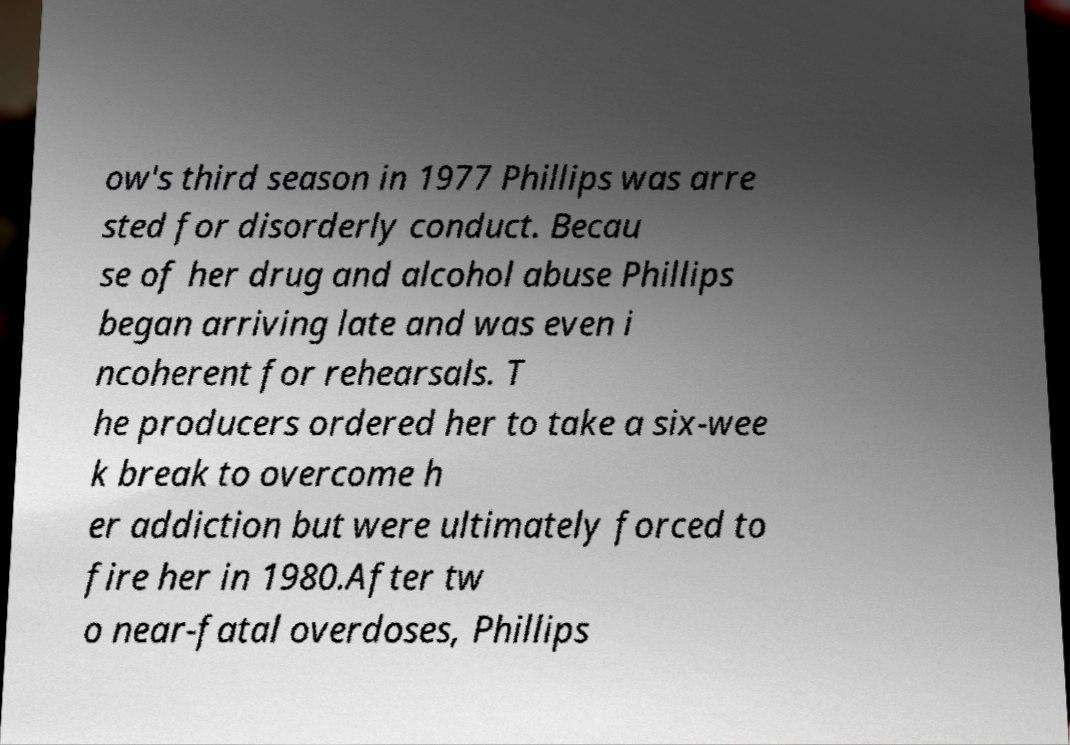Can you read and provide the text displayed in the image?This photo seems to have some interesting text. Can you extract and type it out for me? ow's third season in 1977 Phillips was arre sted for disorderly conduct. Becau se of her drug and alcohol abuse Phillips began arriving late and was even i ncoherent for rehearsals. T he producers ordered her to take a six-wee k break to overcome h er addiction but were ultimately forced to fire her in 1980.After tw o near-fatal overdoses, Phillips 